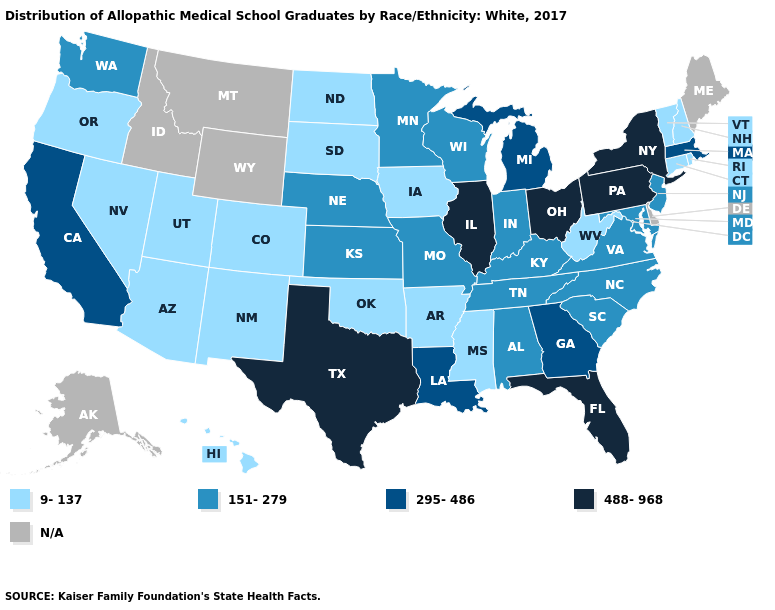What is the value of New Hampshire?
Be succinct. 9-137. What is the value of Kentucky?
Write a very short answer. 151-279. Which states hav the highest value in the West?
Keep it brief. California. What is the value of Georgia?
Be succinct. 295-486. Among the states that border Missouri , which have the lowest value?
Write a very short answer. Arkansas, Iowa, Oklahoma. Does the map have missing data?
Write a very short answer. Yes. What is the value of Kentucky?
Be succinct. 151-279. Name the states that have a value in the range 151-279?
Answer briefly. Alabama, Indiana, Kansas, Kentucky, Maryland, Minnesota, Missouri, Nebraska, New Jersey, North Carolina, South Carolina, Tennessee, Virginia, Washington, Wisconsin. What is the value of West Virginia?
Answer briefly. 9-137. Is the legend a continuous bar?
Be succinct. No. Name the states that have a value in the range 9-137?
Concise answer only. Arizona, Arkansas, Colorado, Connecticut, Hawaii, Iowa, Mississippi, Nevada, New Hampshire, New Mexico, North Dakota, Oklahoma, Oregon, Rhode Island, South Dakota, Utah, Vermont, West Virginia. Which states have the highest value in the USA?
Write a very short answer. Florida, Illinois, New York, Ohio, Pennsylvania, Texas. Among the states that border Montana , which have the lowest value?
Answer briefly. North Dakota, South Dakota. Name the states that have a value in the range N/A?
Concise answer only. Alaska, Delaware, Idaho, Maine, Montana, Wyoming. 